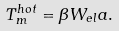Convert formula to latex. <formula><loc_0><loc_0><loc_500><loc_500>T ^ { h o t } _ { m } = \beta W _ { e l } a .</formula> 